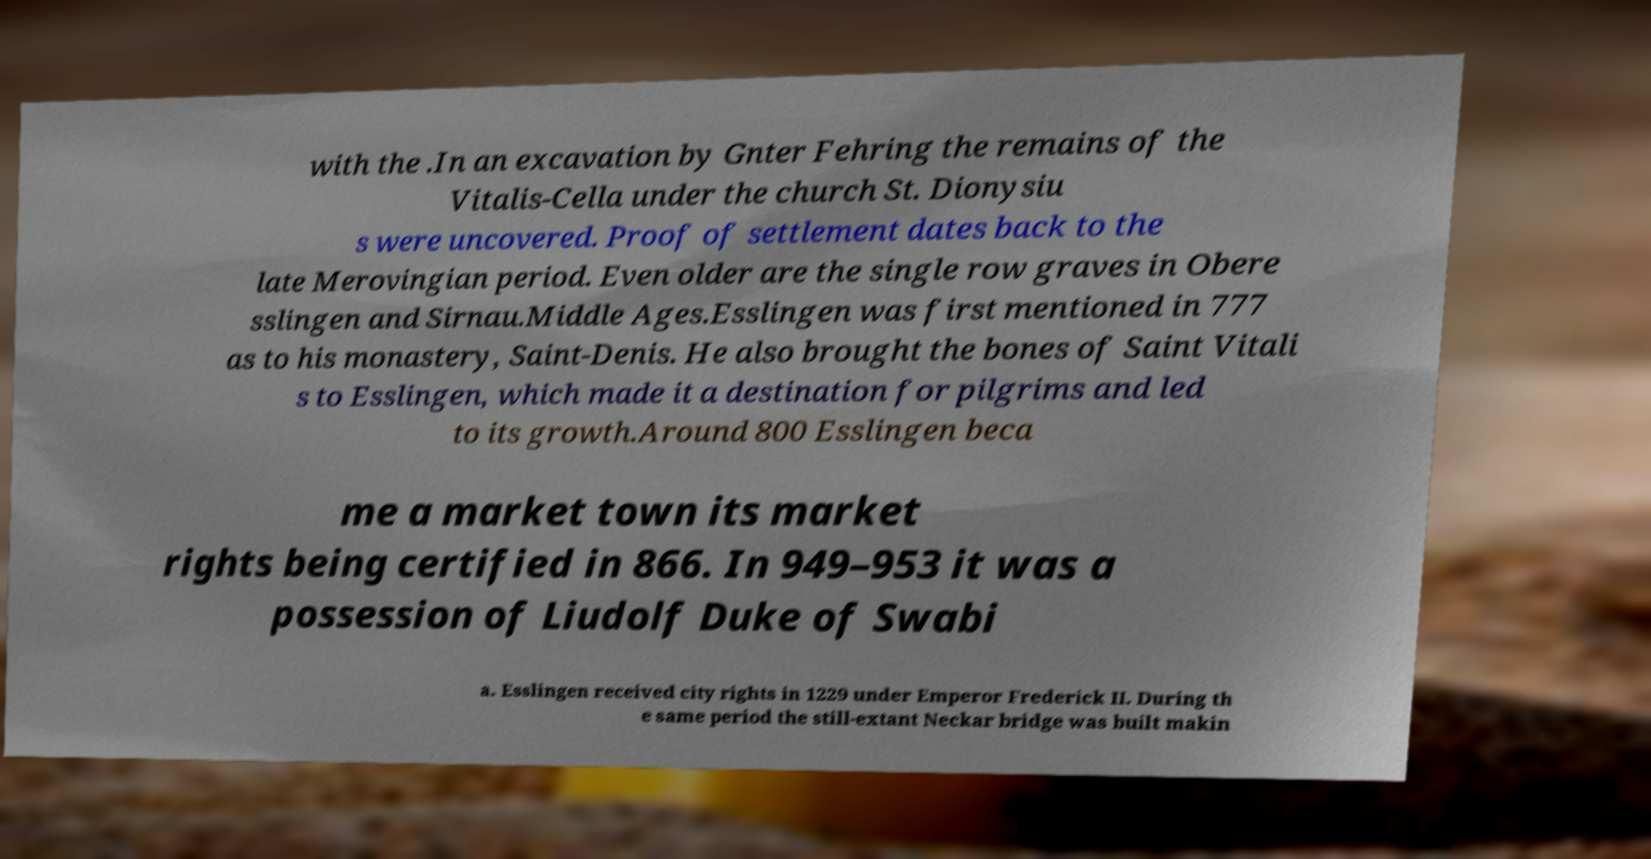Please read and relay the text visible in this image. What does it say? with the .In an excavation by Gnter Fehring the remains of the Vitalis-Cella under the church St. Dionysiu s were uncovered. Proof of settlement dates back to the late Merovingian period. Even older are the single row graves in Obere sslingen and Sirnau.Middle Ages.Esslingen was first mentioned in 777 as to his monastery, Saint-Denis. He also brought the bones of Saint Vitali s to Esslingen, which made it a destination for pilgrims and led to its growth.Around 800 Esslingen beca me a market town its market rights being certified in 866. In 949–953 it was a possession of Liudolf Duke of Swabi a. Esslingen received city rights in 1229 under Emperor Frederick II. During th e same period the still-extant Neckar bridge was built makin 